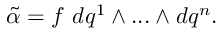<formula> <loc_0><loc_0><loc_500><loc_500>{ \tilde { \alpha } } = f d q ^ { 1 } \wedge \dots \wedge d q ^ { n } .</formula> 